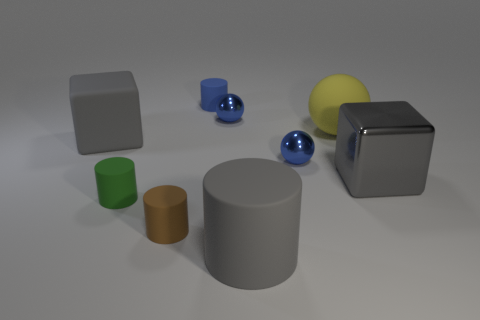How many gray cubes must be subtracted to get 1 gray cubes? 1 Subtract all spheres. How many objects are left? 6 Subtract all small green cylinders. Subtract all shiny balls. How many objects are left? 6 Add 8 rubber spheres. How many rubber spheres are left? 9 Add 3 large purple matte cylinders. How many large purple matte cylinders exist? 3 Subtract 0 yellow cubes. How many objects are left? 9 